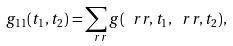<formula> <loc_0><loc_0><loc_500><loc_500>g _ { 1 1 } ( t _ { 1 } , t _ { 2 } ) = \sum _ { \ r r } g ( \ r r , t _ { 1 } , \ r r , t _ { 2 } ) ,</formula> 